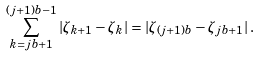Convert formula to latex. <formula><loc_0><loc_0><loc_500><loc_500>\sum _ { k = j b + 1 } ^ { ( j + 1 ) b - 1 } | \zeta _ { k + 1 } - \zeta _ { k } | = | \zeta _ { ( j + 1 ) b } - \zeta _ { j b + 1 } | \, .</formula> 